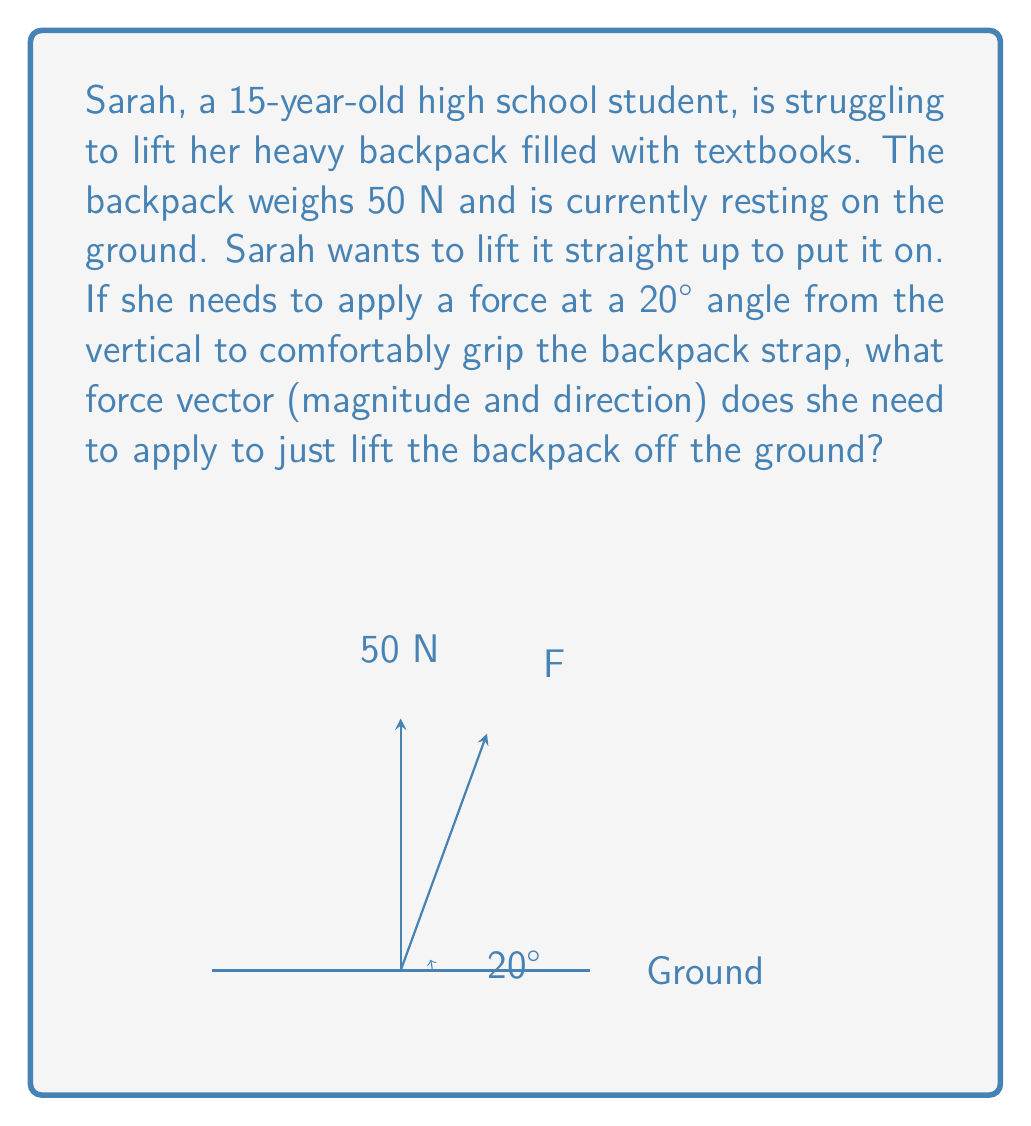What is the answer to this math problem? Let's approach this step-by-step:

1) First, we need to understand that the force Sarah applies (F) must have a vertical component equal to the weight of the backpack (50 N) to lift it.

2) We can represent the force vector F in terms of its vertical (y) and horizontal (x) components:
   $$F_y = F \cos(20°)$$
   $$F_x = F \sin(20°)$$

3) We know that $F_y$ must equal 50 N to lift the backpack:
   $$F \cos(20°) = 50 N$$

4) To find F, we divide both sides by $\cos(20°)$:
   $$F = \frac{50 N}{\cos(20°)} = \frac{50}{0.9397} \approx 53.21 N$$

5) Now that we have the magnitude of F, we can find its components:
   $$F_y = 53.21 \cos(20°) = 50 N$$
   $$F_x = 53.21 \sin(20°) = 18.21 N$$

6) The force vector can be expressed as:
   $$\vec{F} = 18.21\hat{i} + 50\hat{j} \text{ N}$$

7) The direction of the force is already given as 20° from the vertical. We can confirm this:
   $$\tan^{-1}(\frac{F_x}{F_y}) = \tan^{-1}(\frac{18.21}{50}) \approx 20°$$

Therefore, Sarah needs to apply a force of magnitude 53.21 N at an angle of 20° from the vertical to lift her backpack.
Answer: $\vec{F} = 53.21 \text{ N at } 20°$ from vertical, or $\vec{F} = 18.21\hat{i} + 50\hat{j} \text{ N}$ 